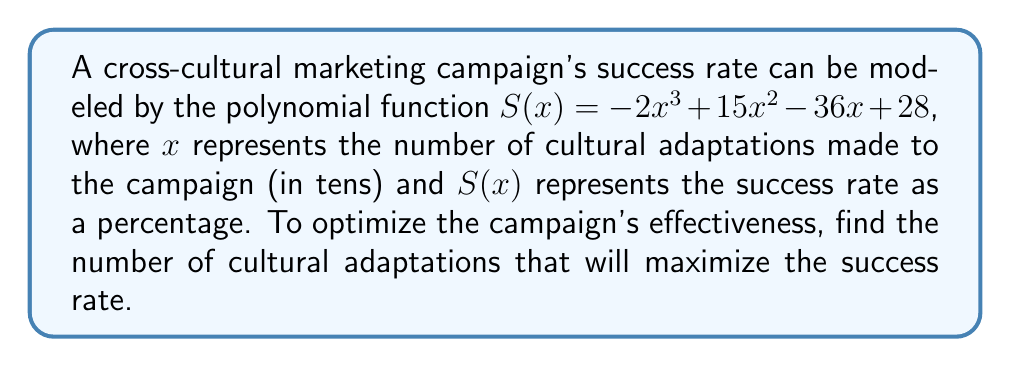Give your solution to this math problem. To find the maximum success rate, we need to follow these steps:

1) First, we need to find the derivative of $S(x)$:
   $$S'(x) = -6x^2 + 30x - 36$$

2) To find the critical points, set $S'(x) = 0$:
   $$-6x^2 + 30x - 36 = 0$$

3) This is a quadratic equation. We can solve it using the quadratic formula:
   $$x = \frac{-b \pm \sqrt{b^2 - 4ac}}{2a}$$
   where $a = -6$, $b = 30$, and $c = -36$

4) Substituting these values:
   $$x = \frac{-30 \pm \sqrt{30^2 - 4(-6)(-36)}}{2(-6)}$$
   $$x = \frac{-30 \pm \sqrt{900 - 864}}{-12}$$
   $$x = \frac{-30 \pm \sqrt{36}}{-12}$$
   $$x = \frac{-30 \pm 6}{-12}$$

5) This gives us two solutions:
   $$x = \frac{-30 + 6}{-12} = 2 \text{ or } x = \frac{-30 - 6}{-12} = 3$$

6) To determine which of these gives the maximum, we can check the second derivative:
   $$S''(x) = -12x + 30$$

7) Evaluating $S''(x)$ at $x = 2$ and $x = 3$:
   $$S''(2) = -12(2) + 30 = 6 > 0$$
   $$S''(3) = -12(3) + 30 = -6 < 0$$

8) Since $S''(2) > 0$, $x = 2$ gives us a local minimum. Therefore, $x = 3$ must give us the local maximum.

9) Remember that $x$ represents tens of adaptations. So $x = 3$ means 30 adaptations.
Answer: The success rate of the cross-cultural marketing campaign is maximized when 30 cultural adaptations are made to the campaign. 